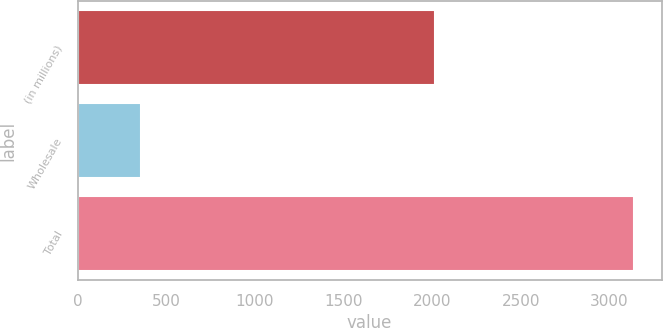Convert chart to OTSL. <chart><loc_0><loc_0><loc_500><loc_500><bar_chart><fcel>(in millions)<fcel>Wholesale<fcel>Total<nl><fcel>2014<fcel>359<fcel>3139<nl></chart> 